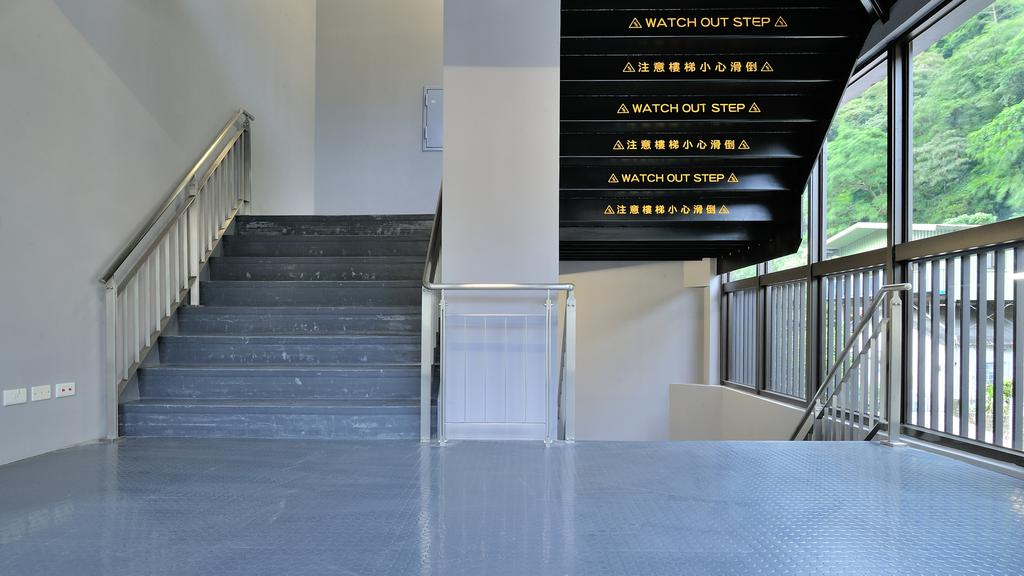What type of surface is visible in the image? There is a floor in the image. What feature is present to provide support or safety? Railings are present in the image. What architectural element allows for movement between different levels? Steps are visible in the image. What devices are mounted on the wall in the image? There are switch boards on the wall in the image. What type of written or printed information is present in the image? Text is present in the image. What type of transparent material is used for windows in the image? Glass windows are visible in the image. What can be seen through the windows in the image? Trees and a building are visible through the windows. How much income does the building generate in the image? The image does not provide any information about the income generated by the building. 